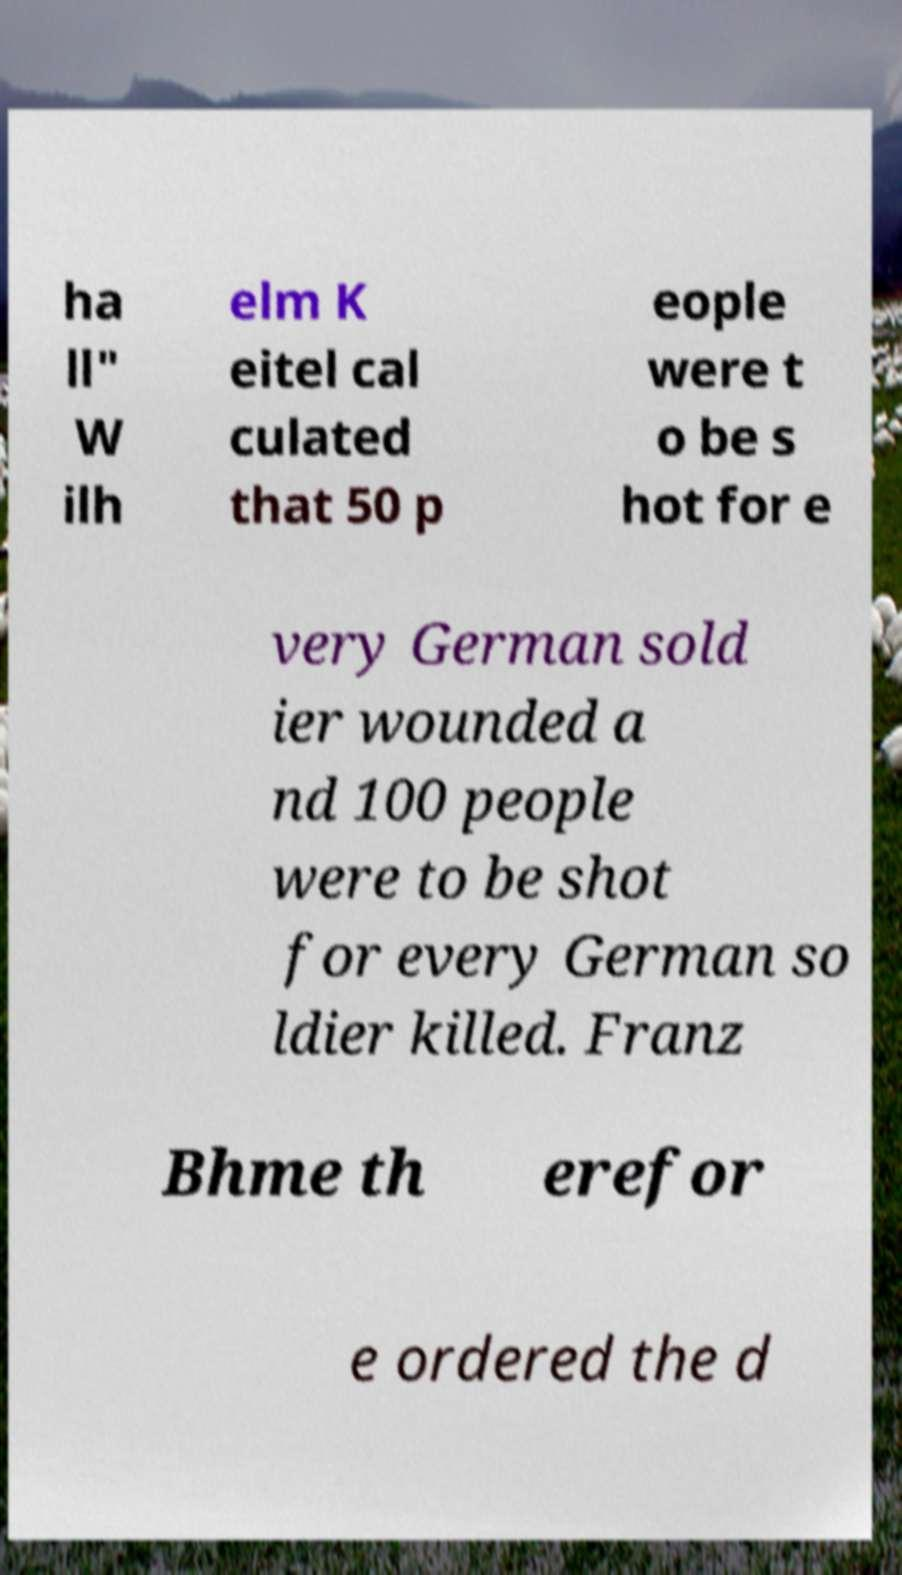Please identify and transcribe the text found in this image. ha ll" W ilh elm K eitel cal culated that 50 p eople were t o be s hot for e very German sold ier wounded a nd 100 people were to be shot for every German so ldier killed. Franz Bhme th erefor e ordered the d 